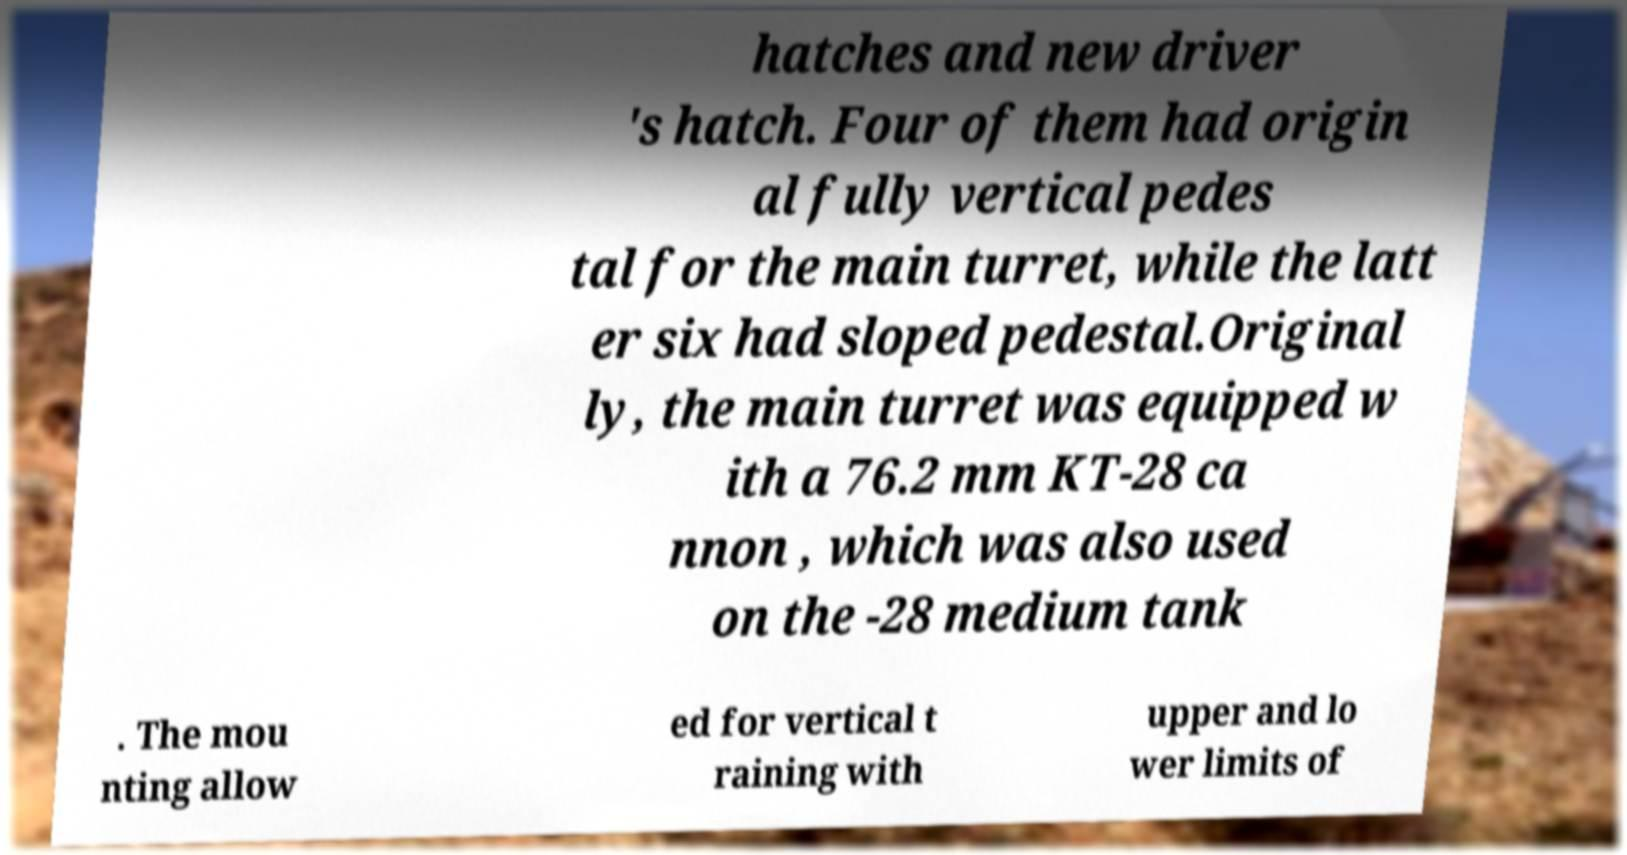I need the written content from this picture converted into text. Can you do that? hatches and new driver 's hatch. Four of them had origin al fully vertical pedes tal for the main turret, while the latt er six had sloped pedestal.Original ly, the main turret was equipped w ith a 76.2 mm KT-28 ca nnon , which was also used on the -28 medium tank . The mou nting allow ed for vertical t raining with upper and lo wer limits of 